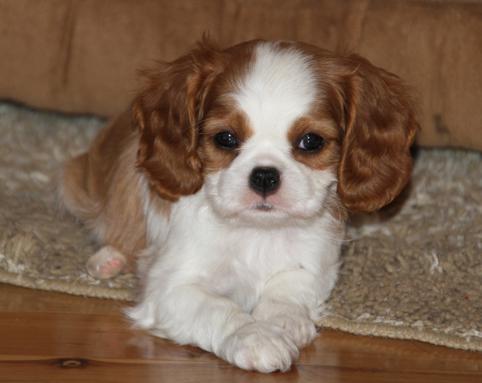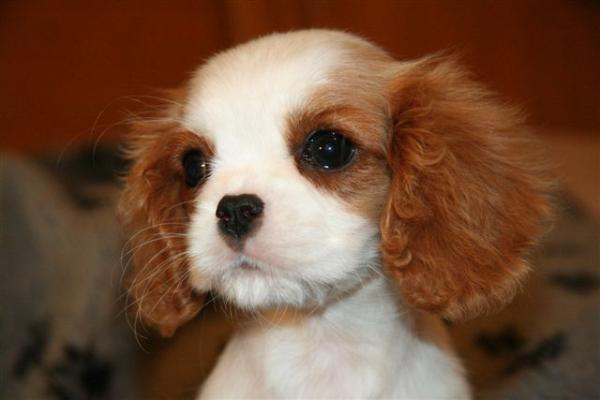The first image is the image on the left, the second image is the image on the right. For the images displayed, is the sentence "An image shows a yellow toy next to at least one dog." factually correct? Answer yes or no. No. The first image is the image on the left, the second image is the image on the right. Considering the images on both sides, is "There are more dogs in the image on the right than the image on the left." valid? Answer yes or no. No. 